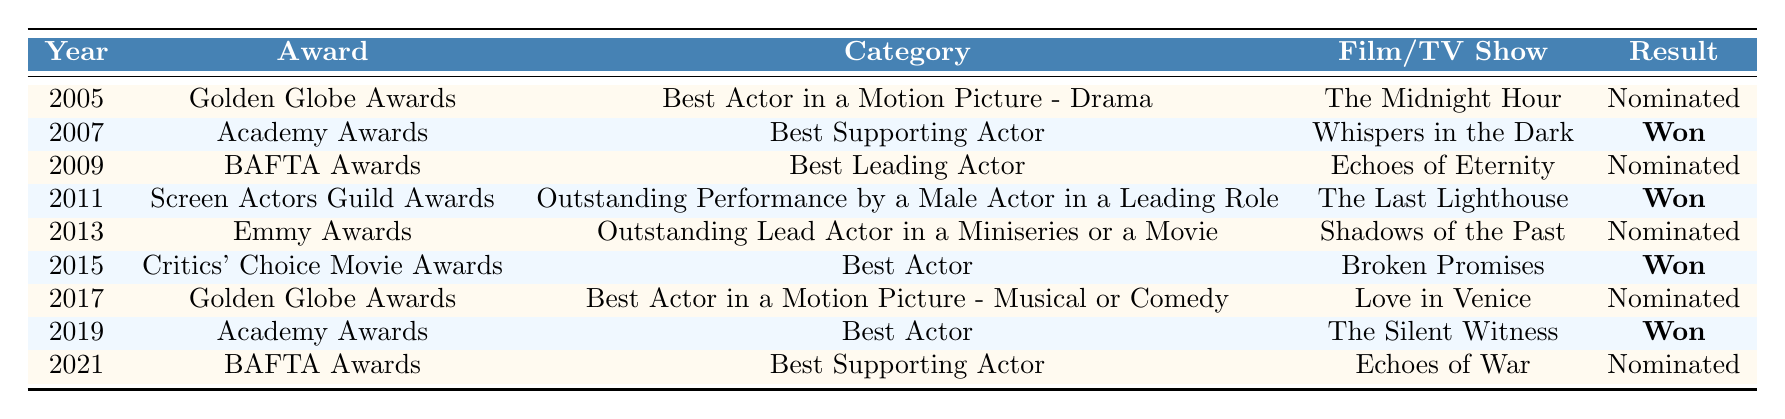What year did Mark Afflick win his first Academy Award? In the table, the first record related to the Academy Awards shows the year 2007 where he won for "Best Supporting Actor."
Answer: 2007 How many times has Mark Afflick been nominated for Golden Globe Awards? The table lists two entries for Golden Globe Awards: one in 2005 and another in 2017, both of which indicate nominations.
Answer: 2 Which film earned Mark Afflick a win at the Critics' Choice Movie Awards? The entry for the Critics' Choice Movie Awards in 2015 specifies that he won for the film "Broken Promises."
Answer: Broken Promises Did Mark Afflick ever win a nomination for an Emmy Award? According to the table, Mark Afflick was nominated for an Emmy Award in 2013 but did not win, therefore the answer is no.
Answer: No What is the total number of wins Mark Afflick has achieved according to the table? By identifying the entries marked as "Won," we see three wins in total: 2007 (Academy Awards), 2011 (Screen Actors Guild Awards), and 2015 (Critics' Choice Movie Awards).
Answer: 3 Which category had the most nominations for Mark Afflick? The "Best Actor" category appears twice (Golden Globe in 2017 and Academy Awards in 2019) while other categories are only nominated once, indicating "Best Actor" has the most nominations.
Answer: Best Actor In which year did Mark Afflick receive the most recent nomination? The last entry in the table is for the year 2021 where he was nominated for a BAFTA Award.
Answer: 2021 What percentage of awards nominations resulted in wins for Mark Afflick? There are 8 nominations (5 wins and 3 losses), hence the percentage of wins is calculated as (3 wins/8 nominations) * 100 = 37.5%.
Answer: 37.5% How many different films did Mark Afflick receive nominations for? By counting the unique films listed for all nominations, there are 6 different films: "The Midnight Hour," "Whispers in the Dark," "Echoes of Eternity," "The Last Lighthouse," "Shadows of the Past," and "Love in Venice."
Answer: 6 What is the earliest and latest year listed for Mark Afflick's nominations and wins? The earliest nomination year listed is 2005, and the latest year for a nomination is 2021, showcasing the range of his career spanning 16 years.
Answer: 2005 and 2021 